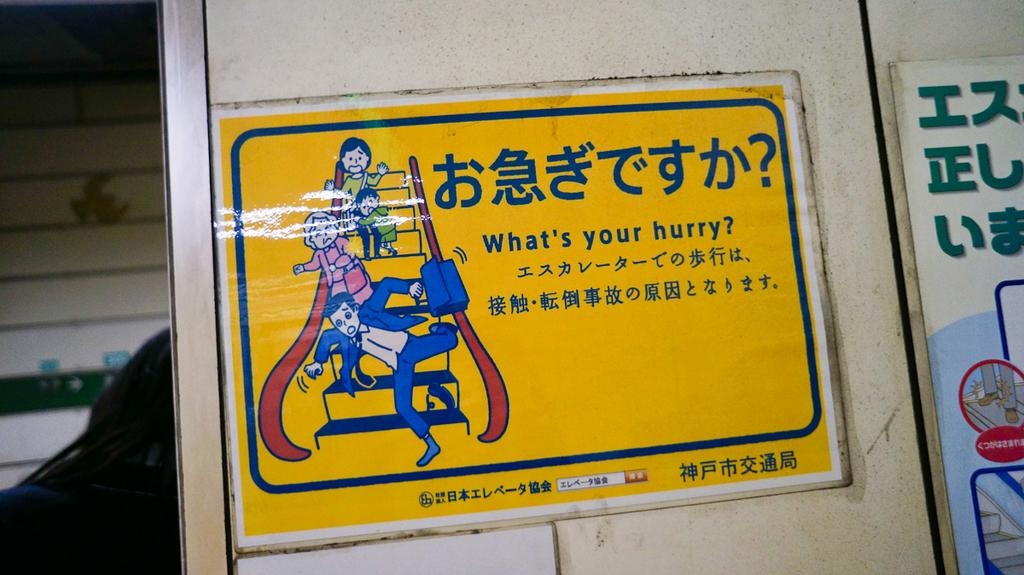<image>
Give a short and clear explanation of the subsequent image. the question of what's your hurry is written on a yellow sign 